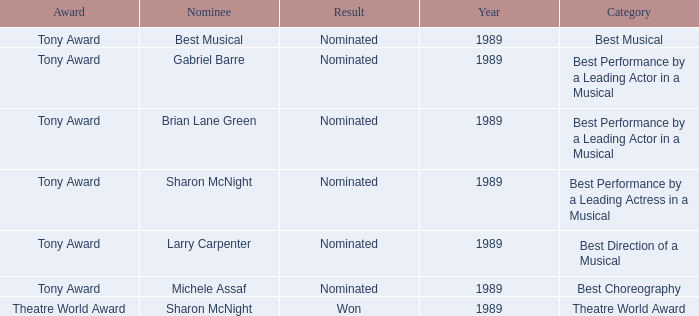What was the nominee of best musical Best Musical. 